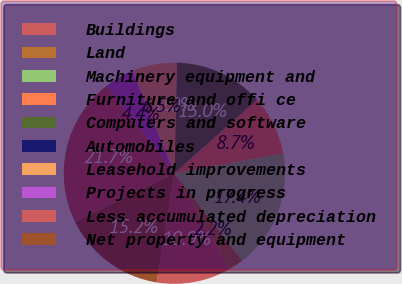Convert chart. <chart><loc_0><loc_0><loc_500><loc_500><pie_chart><fcel>Buildings<fcel>Land<fcel>Machinery equipment and<fcel>Furniture and offi ce<fcel>Computers and software<fcel>Automobiles<fcel>Leasehold improvements<fcel>Projects in progress<fcel>Less accumulated depreciation<fcel>Net property and equipment<nl><fcel>10.87%<fcel>2.2%<fcel>17.36%<fcel>8.7%<fcel>13.03%<fcel>0.04%<fcel>6.54%<fcel>4.37%<fcel>21.69%<fcel>15.2%<nl></chart> 